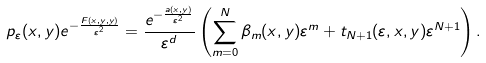<formula> <loc_0><loc_0><loc_500><loc_500>p _ { \varepsilon } ( x , y ) e ^ { - \frac { F ( x , y , y ) } { \varepsilon ^ { 2 } } } = \frac { e ^ { - \frac { a ( x , y ) } { \varepsilon ^ { 2 } } } } { \varepsilon ^ { d } } \left ( \sum _ { m = 0 } ^ { N } \beta _ { m } ( x , y ) \varepsilon ^ { m } + t _ { N + 1 } ( \varepsilon , x , y ) \varepsilon ^ { N + 1 } \right ) .</formula> 